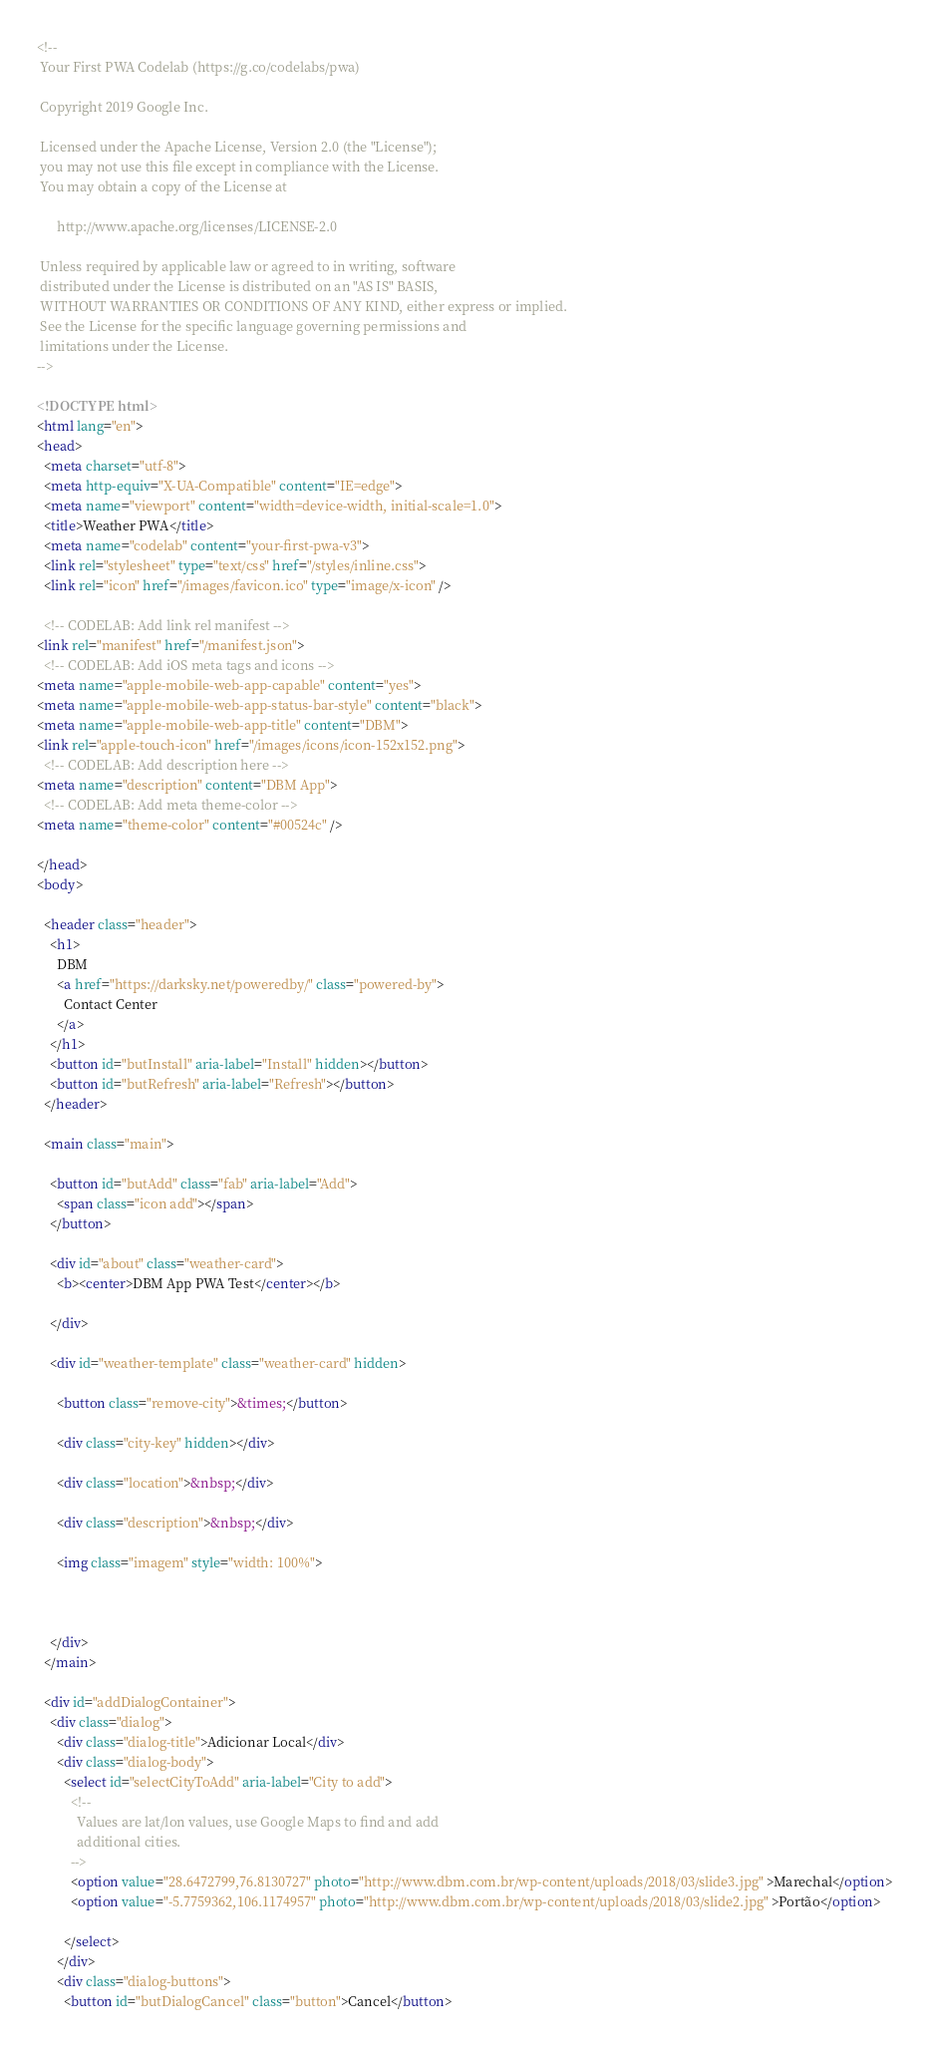Convert code to text. <code><loc_0><loc_0><loc_500><loc_500><_HTML_><!--
 Your First PWA Codelab (https://g.co/codelabs/pwa)

 Copyright 2019 Google Inc.

 Licensed under the Apache License, Version 2.0 (the "License");
 you may not use this file except in compliance with the License.
 You may obtain a copy of the License at

      http://www.apache.org/licenses/LICENSE-2.0

 Unless required by applicable law or agreed to in writing, software
 distributed under the License is distributed on an "AS IS" BASIS,
 WITHOUT WARRANTIES OR CONDITIONS OF ANY KIND, either express or implied.
 See the License for the specific language governing permissions and
 limitations under the License.
-->

<!DOCTYPE html>
<html lang="en">
<head>
  <meta charset="utf-8">
  <meta http-equiv="X-UA-Compatible" content="IE=edge">
  <meta name="viewport" content="width=device-width, initial-scale=1.0">
  <title>Weather PWA</title>
  <meta name="codelab" content="your-first-pwa-v3">
  <link rel="stylesheet" type="text/css" href="/styles/inline.css">
  <link rel="icon" href="/images/favicon.ico" type="image/x-icon" />

  <!-- CODELAB: Add link rel manifest -->
<link rel="manifest" href="/manifest.json">
  <!-- CODELAB: Add iOS meta tags and icons -->
<meta name="apple-mobile-web-app-capable" content="yes">
<meta name="apple-mobile-web-app-status-bar-style" content="black">
<meta name="apple-mobile-web-app-title" content="DBM">
<link rel="apple-touch-icon" href="/images/icons/icon-152x152.png">
  <!-- CODELAB: Add description here -->
<meta name="description" content="DBM App">
  <!-- CODELAB: Add meta theme-color -->
<meta name="theme-color" content="#00524c" />

</head>
<body>

  <header class="header">
    <h1>
      DBM
      <a href="https://darksky.net/poweredby/" class="powered-by">
        Contact Center
      </a>
    </h1>
    <button id="butInstall" aria-label="Install" hidden></button>
    <button id="butRefresh" aria-label="Refresh"></button>
  </header>

  <main class="main">

    <button id="butAdd" class="fab" aria-label="Add">
      <span class="icon add"></span>
    </button>

    <div id="about" class="weather-card">
      <b><center>DBM App PWA Test</center></b>
      
    </div>

    <div id="weather-template" class="weather-card" hidden>

      <button class="remove-city">&times;</button>
      
      <div class="city-key" hidden></div>
     
      <div class="location">&nbsp;</div>
      
      <div class="description">&nbsp;</div>

      <img class="imagem" style="width: 100%">
     
     

    </div>
  </main>

  <div id="addDialogContainer">
    <div class="dialog">
      <div class="dialog-title">Adicionar Local</div>
      <div class="dialog-body">
        <select id="selectCityToAdd" aria-label="City to add">
          <!--
            Values are lat/lon values, use Google Maps to find and add
            additional cities.
          -->
          <option value="28.6472799,76.8130727" photo="http://www.dbm.com.br/wp-content/uploads/2018/03/slide3.jpg" >Marechal</option>
          <option value="-5.7759362,106.1174957" photo="http://www.dbm.com.br/wp-content/uploads/2018/03/slide2.jpg" >Portão</option>

        </select>
      </div>
      <div class="dialog-buttons">
        <button id="butDialogCancel" class="button">Cancel</button></code> 